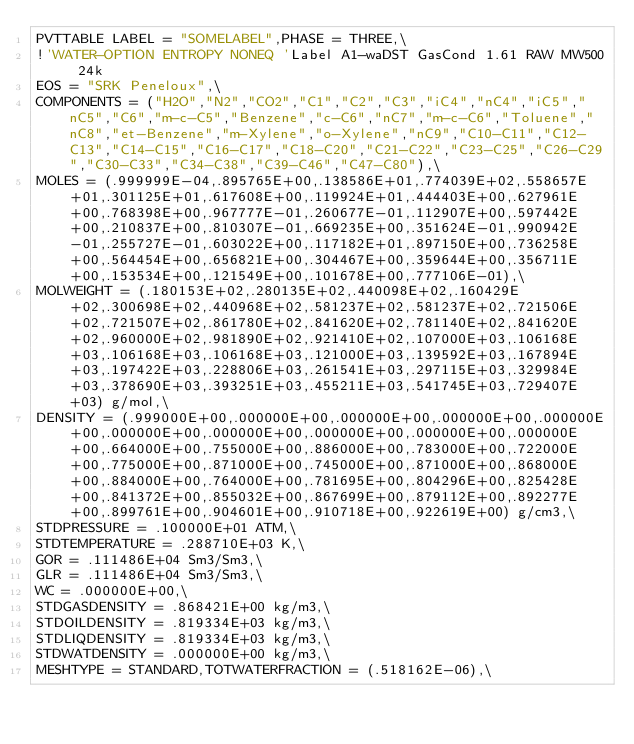<code> <loc_0><loc_0><loc_500><loc_500><_SQL_>PVTTABLE LABEL = "SOMELABEL",PHASE = THREE,\
!'WATER-OPTION ENTROPY NONEQ 'Label A1-waDST GasCond 1.61 RAW MW500 24k
EOS = "SRK Peneloux",\
COMPONENTS = ("H2O","N2","CO2","C1","C2","C3","iC4","nC4","iC5","nC5","C6","m-c-C5","Benzene","c-C6","nC7","m-c-C6","Toluene","nC8","et-Benzene","m-Xylene","o-Xylene","nC9","C10-C11","C12-C13","C14-C15","C16-C17","C18-C20","C21-C22","C23-C25","C26-C29","C30-C33","C34-C38","C39-C46","C47-C80"),\
MOLES = (.999999E-04,.895765E+00,.138586E+01,.774039E+02,.558657E+01,.301125E+01,.617608E+00,.119924E+01,.444403E+00,.627961E+00,.768398E+00,.967777E-01,.260677E-01,.112907E+00,.597442E+00,.210837E+00,.810307E-01,.669235E+00,.351624E-01,.990942E-01,.255727E-01,.603022E+00,.117182E+01,.897150E+00,.736258E+00,.564454E+00,.656821E+00,.304467E+00,.359644E+00,.356711E+00,.153534E+00,.121549E+00,.101678E+00,.777106E-01),\
MOLWEIGHT = (.180153E+02,.280135E+02,.440098E+02,.160429E+02,.300698E+02,.440968E+02,.581237E+02,.581237E+02,.721506E+02,.721507E+02,.861780E+02,.841620E+02,.781140E+02,.841620E+02,.960000E+02,.981890E+02,.921410E+02,.107000E+03,.106168E+03,.106168E+03,.106168E+03,.121000E+03,.139592E+03,.167894E+03,.197422E+03,.228806E+03,.261541E+03,.297115E+03,.329984E+03,.378690E+03,.393251E+03,.455211E+03,.541745E+03,.729407E+03) g/mol,\
DENSITY = (.999000E+00,.000000E+00,.000000E+00,.000000E+00,.000000E+00,.000000E+00,.000000E+00,.000000E+00,.000000E+00,.000000E+00,.664000E+00,.755000E+00,.886000E+00,.783000E+00,.722000E+00,.775000E+00,.871000E+00,.745000E+00,.871000E+00,.868000E+00,.884000E+00,.764000E+00,.781695E+00,.804296E+00,.825428E+00,.841372E+00,.855032E+00,.867699E+00,.879112E+00,.892277E+00,.899761E+00,.904601E+00,.910718E+00,.922619E+00) g/cm3,\
STDPRESSURE = .100000E+01 ATM,\
STDTEMPERATURE = .288710E+03 K,\
GOR = .111486E+04 Sm3/Sm3,\
GLR = .111486E+04 Sm3/Sm3,\
WC = .000000E+00,\
STDGASDENSITY = .868421E+00 kg/m3,\
STDOILDENSITY = .819334E+03 kg/m3,\
STDLIQDENSITY = .819334E+03 kg/m3,\
STDWATDENSITY = .000000E+00 kg/m3,\
MESHTYPE = STANDARD,TOTWATERFRACTION = (.518162E-06),\</code> 